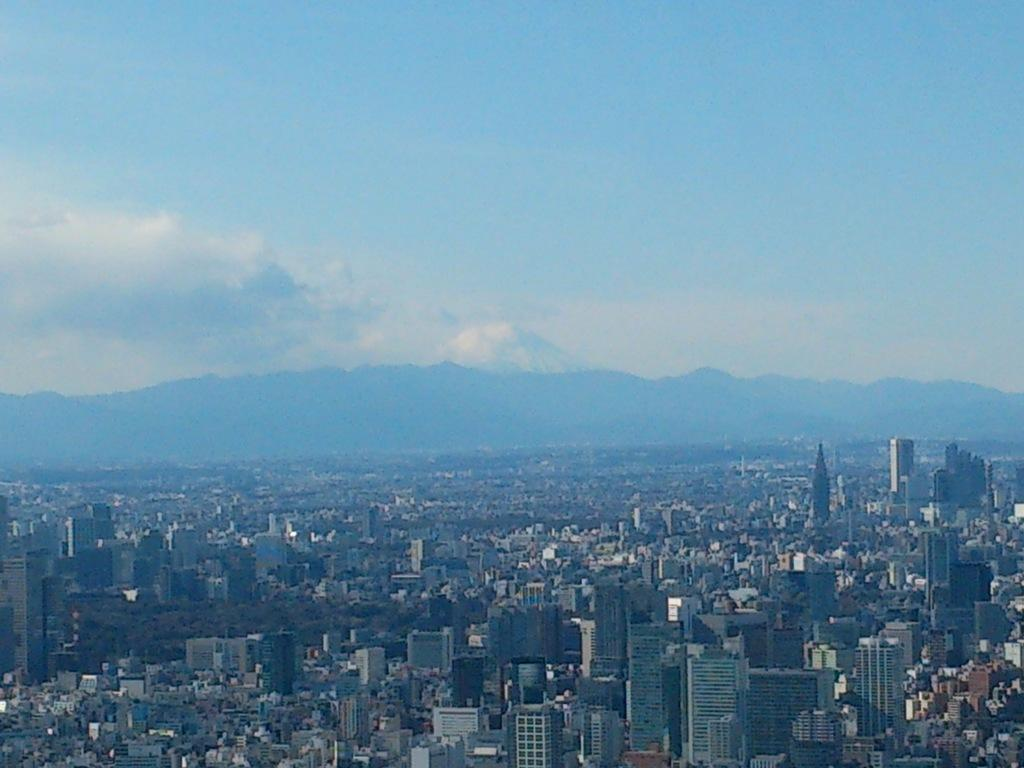What type of view is shown in the image? The image is an aerial view of the city. What structures can be seen in the image? There are buildings and houses in the image. Are there any natural elements visible in the image? Yes, there are trees in the image. What part of the sky is visible in the image? The sky is visible in the image. What can be observed in the sky? Clouds are present in the sky. Where is the boy playing in the downtown area in the image? There is no boy present in the image, and the downtown area is not mentioned. 